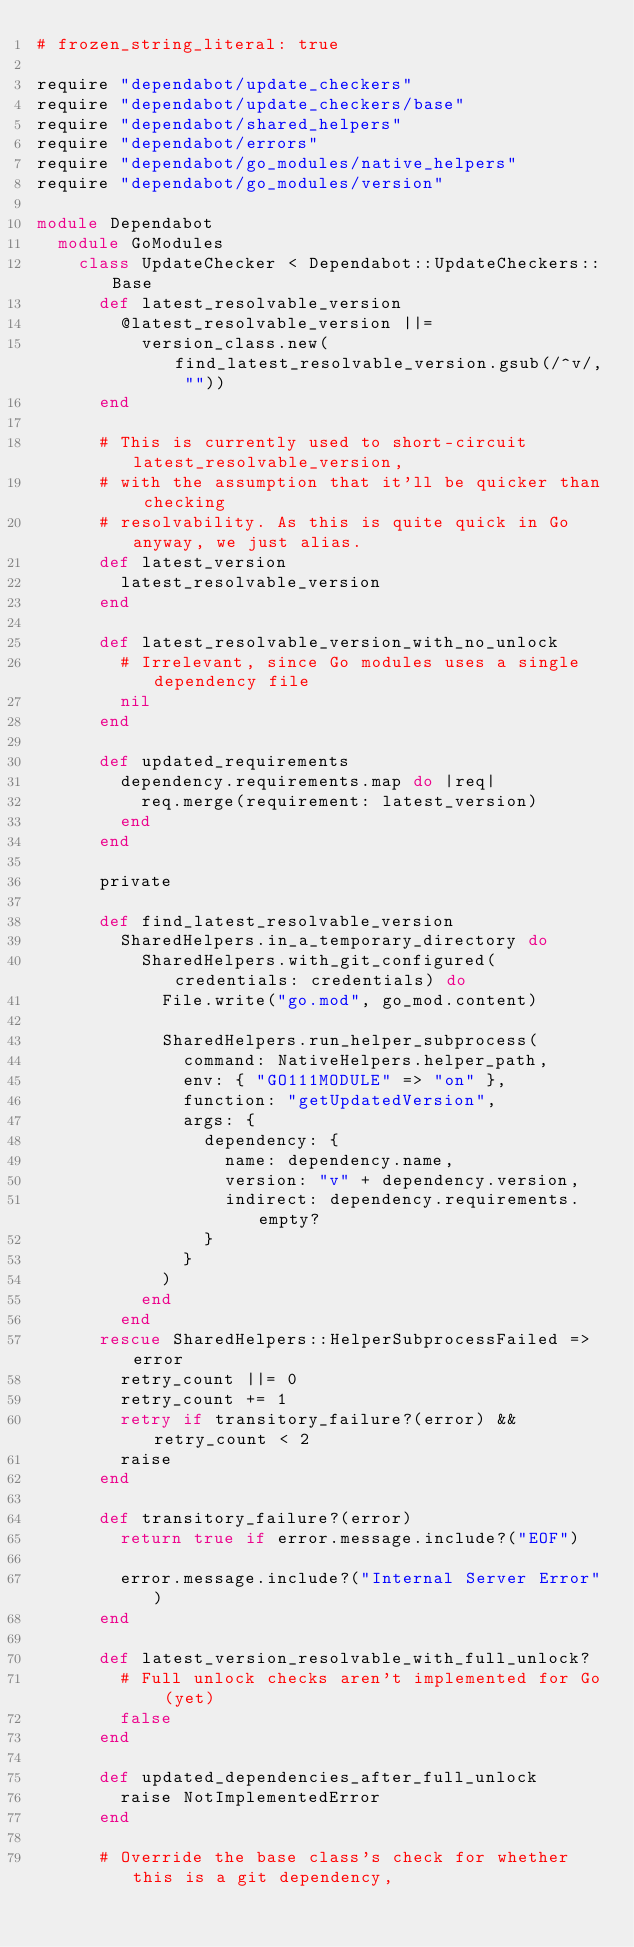Convert code to text. <code><loc_0><loc_0><loc_500><loc_500><_Ruby_># frozen_string_literal: true

require "dependabot/update_checkers"
require "dependabot/update_checkers/base"
require "dependabot/shared_helpers"
require "dependabot/errors"
require "dependabot/go_modules/native_helpers"
require "dependabot/go_modules/version"

module Dependabot
  module GoModules
    class UpdateChecker < Dependabot::UpdateCheckers::Base
      def latest_resolvable_version
        @latest_resolvable_version ||=
          version_class.new(find_latest_resolvable_version.gsub(/^v/, ""))
      end

      # This is currently used to short-circuit latest_resolvable_version,
      # with the assumption that it'll be quicker than checking
      # resolvability. As this is quite quick in Go anyway, we just alias.
      def latest_version
        latest_resolvable_version
      end

      def latest_resolvable_version_with_no_unlock
        # Irrelevant, since Go modules uses a single dependency file
        nil
      end

      def updated_requirements
        dependency.requirements.map do |req|
          req.merge(requirement: latest_version)
        end
      end

      private

      def find_latest_resolvable_version
        SharedHelpers.in_a_temporary_directory do
          SharedHelpers.with_git_configured(credentials: credentials) do
            File.write("go.mod", go_mod.content)

            SharedHelpers.run_helper_subprocess(
              command: NativeHelpers.helper_path,
              env: { "GO111MODULE" => "on" },
              function: "getUpdatedVersion",
              args: {
                dependency: {
                  name: dependency.name,
                  version: "v" + dependency.version,
                  indirect: dependency.requirements.empty?
                }
              }
            )
          end
        end
      rescue SharedHelpers::HelperSubprocessFailed => error
        retry_count ||= 0
        retry_count += 1
        retry if transitory_failure?(error) && retry_count < 2
        raise
      end

      def transitory_failure?(error)
        return true if error.message.include?("EOF")

        error.message.include?("Internal Server Error")
      end

      def latest_version_resolvable_with_full_unlock?
        # Full unlock checks aren't implemented for Go (yet)
        false
      end

      def updated_dependencies_after_full_unlock
        raise NotImplementedError
      end

      # Override the base class's check for whether this is a git dependency,</code> 